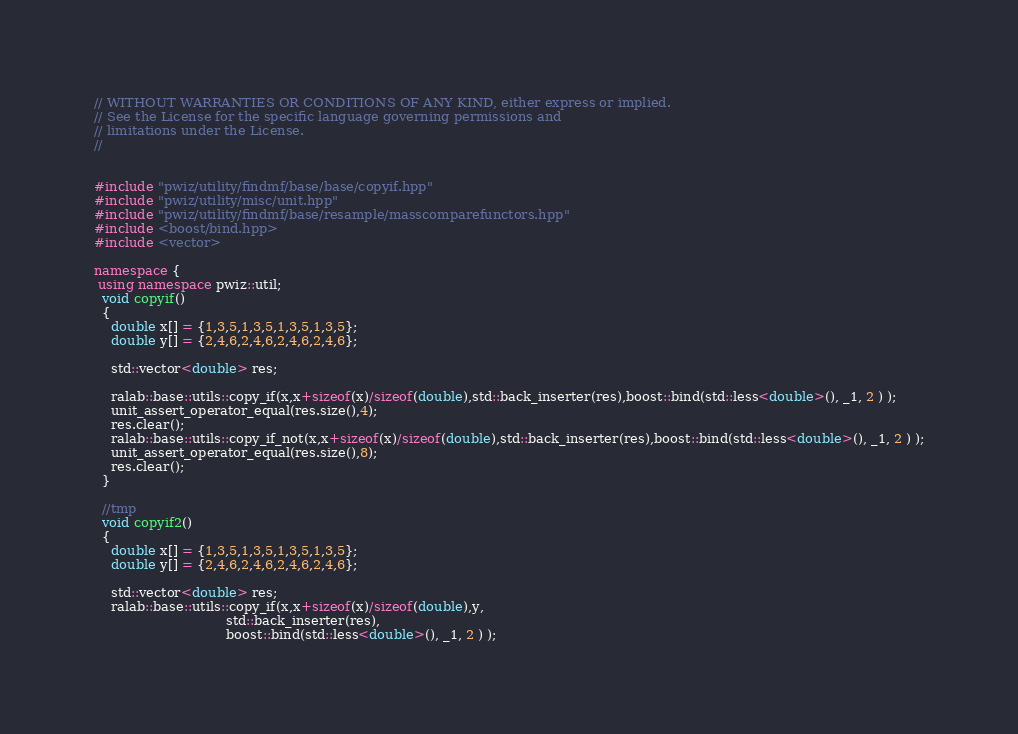Convert code to text. <code><loc_0><loc_0><loc_500><loc_500><_C++_>// WITHOUT WARRANTIES OR CONDITIONS OF ANY KIND, either express or implied. 
// See the License for the specific language governing permissions and 
// limitations under the License.
//


#include "pwiz/utility/findmf/base/base/copyif.hpp"
#include "pwiz/utility/misc/unit.hpp"
#include "pwiz/utility/findmf/base/resample/masscomparefunctors.hpp"
#include <boost/bind.hpp>
#include <vector>

namespace {
 using namespace pwiz::util;
  void copyif()
  {
    double x[] = {1,3,5,1,3,5,1,3,5,1,3,5};
    double y[] = {2,4,6,2,4,6,2,4,6,2,4,6};

    std::vector<double> res;

    ralab::base::utils::copy_if(x,x+sizeof(x)/sizeof(double),std::back_inserter(res),boost::bind(std::less<double>(), _1, 2 ) );
    unit_assert_operator_equal(res.size(),4);
    res.clear();
    ralab::base::utils::copy_if_not(x,x+sizeof(x)/sizeof(double),std::back_inserter(res),boost::bind(std::less<double>(), _1, 2 ) );
    unit_assert_operator_equal(res.size(),8);
    res.clear();
  }

  //tmp
  void copyif2()
  {
    double x[] = {1,3,5,1,3,5,1,3,5,1,3,5};
    double y[] = {2,4,6,2,4,6,2,4,6,2,4,6};

    std::vector<double> res;
    ralab::base::utils::copy_if(x,x+sizeof(x)/sizeof(double),y,
                                std::back_inserter(res),
                                boost::bind(std::less<double>(), _1, 2 ) );</code> 